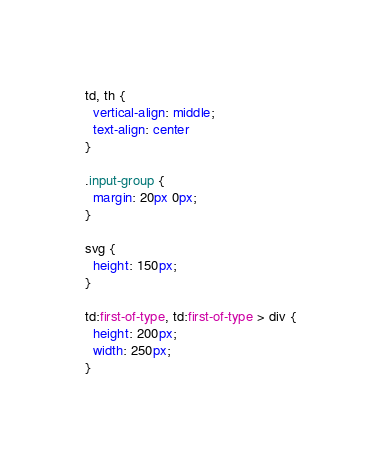Convert code to text. <code><loc_0><loc_0><loc_500><loc_500><_CSS_>td, th {
  vertical-align: middle;
  text-align: center
}

.input-group {
  margin: 20px 0px;
}

svg {
  height: 150px;
}

td:first-of-type, td:first-of-type > div {
  height: 200px;
  width: 250px;
}
</code> 